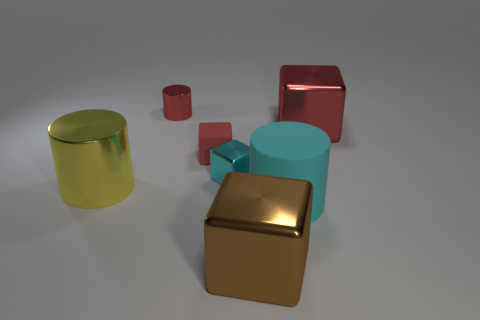How many red blocks must be subtracted to get 1 red blocks? 1 Subtract all tiny red metal cylinders. How many cylinders are left? 2 Add 1 large cyan cylinders. How many objects exist? 8 Subtract all cyan cubes. How many cubes are left? 3 Subtract all yellow blocks. Subtract all brown cylinders. How many blocks are left? 4 Subtract all purple balls. How many red cylinders are left? 1 Subtract all big metallic blocks. Subtract all cylinders. How many objects are left? 2 Add 2 matte cylinders. How many matte cylinders are left? 3 Add 4 cyan rubber objects. How many cyan rubber objects exist? 5 Subtract 2 red cubes. How many objects are left? 5 